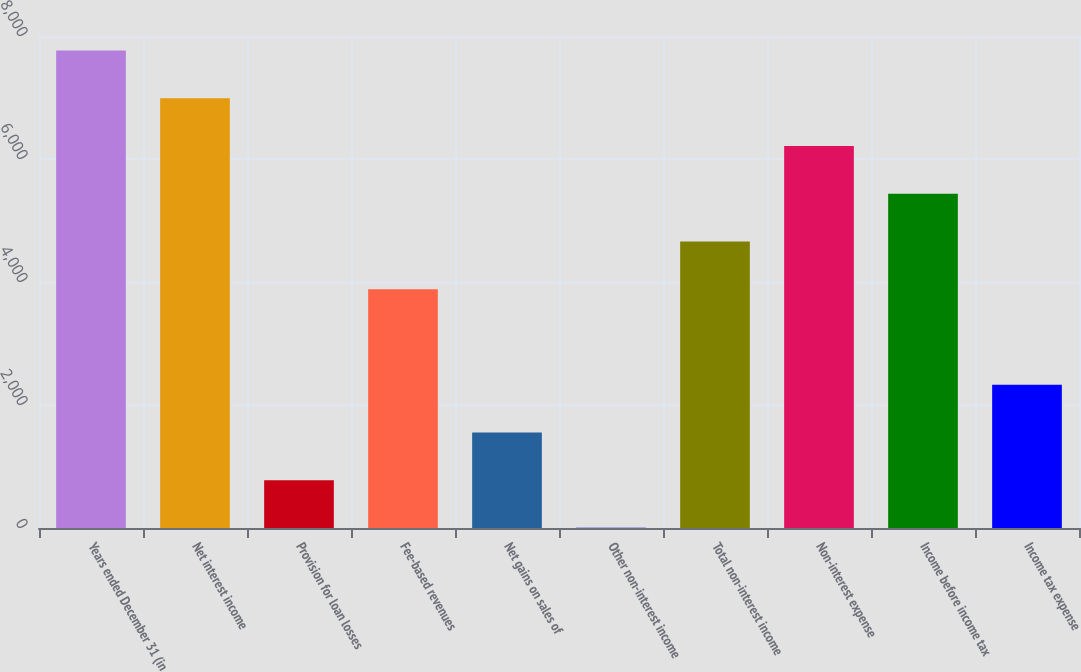Convert chart to OTSL. <chart><loc_0><loc_0><loc_500><loc_500><bar_chart><fcel>Years ended December 31 (in<fcel>Net interest income<fcel>Provision for loan losses<fcel>Fee-based revenues<fcel>Net gains on sales of<fcel>Other non-interest income<fcel>Total non-interest income<fcel>Non-interest expense<fcel>Income before income tax<fcel>Income tax expense<nl><fcel>7762.4<fcel>6986.4<fcel>778.4<fcel>3882.4<fcel>1554.4<fcel>2.4<fcel>4658.4<fcel>6210.4<fcel>5434.4<fcel>2330.4<nl></chart> 